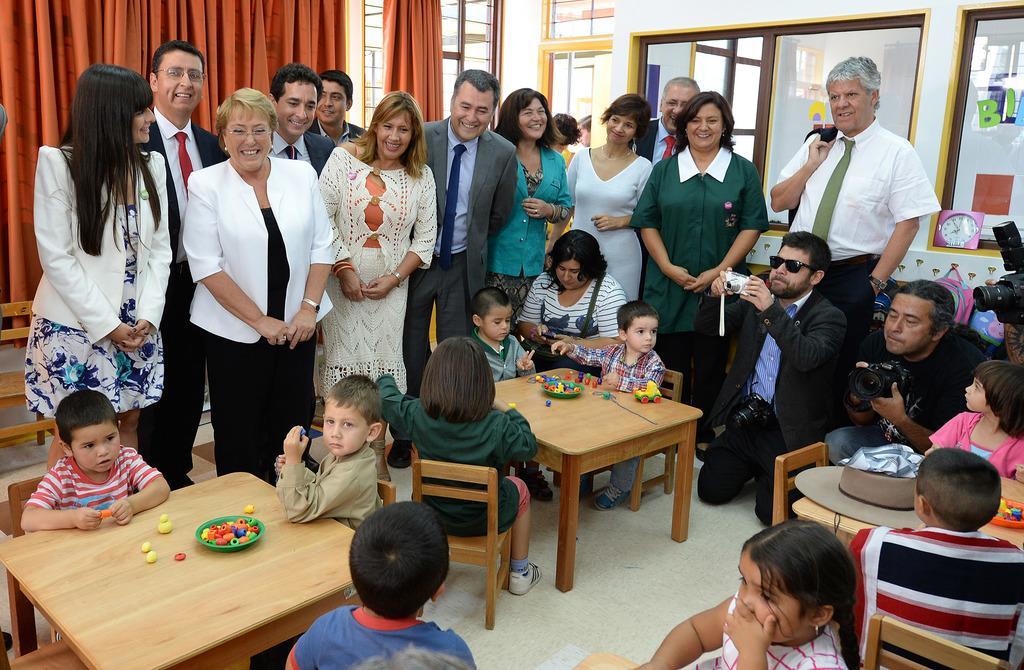Could you give a brief overview of what you see in this image? In this image there are a few people standing with a smile on their face, in front of them there are a few kids seated in chairs are playing with toys which are in front of them on the table, in the background of the image there are doors, windows and curtains. 